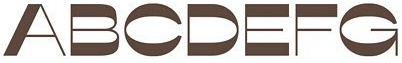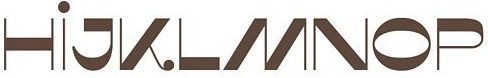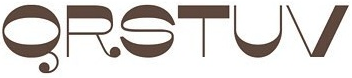Read the text content from these images in order, separated by a semicolon. ABCDEFG; HİJKLMNOP; QRSTUV 